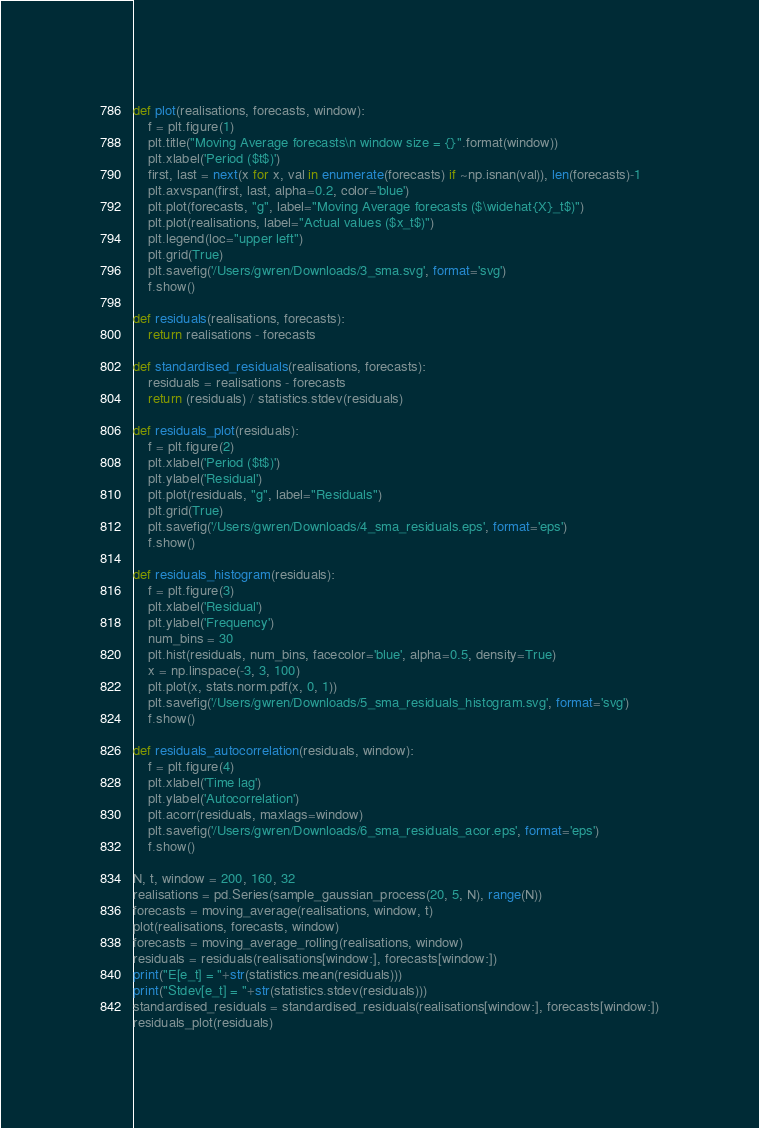Convert code to text. <code><loc_0><loc_0><loc_500><loc_500><_Python_>
def plot(realisations, forecasts, window):
    f = plt.figure(1)
    plt.title("Moving Average forecasts\n window size = {}".format(window))
    plt.xlabel('Period ($t$)')
    first, last = next(x for x, val in enumerate(forecasts) if ~np.isnan(val)), len(forecasts)-1
    plt.axvspan(first, last, alpha=0.2, color='blue')
    plt.plot(forecasts, "g", label="Moving Average forecasts ($\widehat{X}_t$)")
    plt.plot(realisations, label="Actual values ($x_t$)")
    plt.legend(loc="upper left")
    plt.grid(True)
    plt.savefig('/Users/gwren/Downloads/3_sma.svg', format='svg')
    f.show()

def residuals(realisations, forecasts):
    return realisations - forecasts

def standardised_residuals(realisations, forecasts):
    residuals = realisations - forecasts
    return (residuals) / statistics.stdev(residuals)

def residuals_plot(residuals):
    f = plt.figure(2)
    plt.xlabel('Period ($t$)')
    plt.ylabel('Residual')
    plt.plot(residuals, "g", label="Residuals")
    plt.grid(True)
    plt.savefig('/Users/gwren/Downloads/4_sma_residuals.eps', format='eps')
    f.show()

def residuals_histogram(residuals):
    f = plt.figure(3)
    plt.xlabel('Residual')
    plt.ylabel('Frequency')
    num_bins = 30
    plt.hist(residuals, num_bins, facecolor='blue', alpha=0.5, density=True)
    x = np.linspace(-3, 3, 100)
    plt.plot(x, stats.norm.pdf(x, 0, 1))
    plt.savefig('/Users/gwren/Downloads/5_sma_residuals_histogram.svg', format='svg')
    f.show()

def residuals_autocorrelation(residuals, window):
    f = plt.figure(4)
    plt.xlabel('Time lag')
    plt.ylabel('Autocorrelation')
    plt.acorr(residuals, maxlags=window)
    plt.savefig('/Users/gwren/Downloads/6_sma_residuals_acor.eps', format='eps')
    f.show()

N, t, window = 200, 160, 32
realisations = pd.Series(sample_gaussian_process(20, 5, N), range(N))
forecasts = moving_average(realisations, window, t)
plot(realisations, forecasts, window) 
forecasts = moving_average_rolling(realisations, window)
residuals = residuals(realisations[window:], forecasts[window:])
print("E[e_t] = "+str(statistics.mean(residuals)))
print("Stdev[e_t] = "+str(statistics.stdev(residuals)))
standardised_residuals = standardised_residuals(realisations[window:], forecasts[window:])
residuals_plot(residuals)</code> 